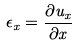<formula> <loc_0><loc_0><loc_500><loc_500>\epsilon _ { x } = \frac { \partial u _ { x } } { \partial x }</formula> 